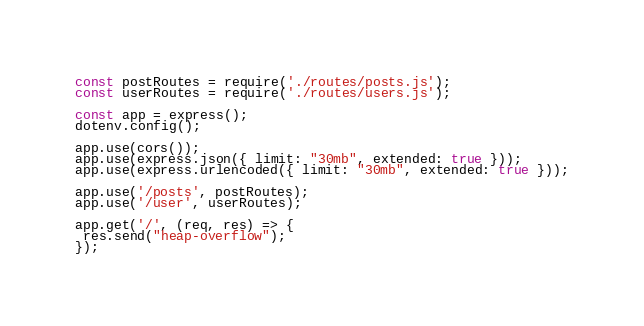<code> <loc_0><loc_0><loc_500><loc_500><_JavaScript_>
const postRoutes = require('./routes/posts.js');
const userRoutes = require('./routes/users.js');

const app = express();
dotenv.config();

app.use(cors());
app.use(express.json({ limit: "30mb", extended: true }));
app.use(express.urlencoded({ limit: "30mb", extended: true }));

app.use('/posts', postRoutes);
app.use('/user', userRoutes);

app.get('/', (req, res) => {
 res.send("heap-overflow");
});
</code> 